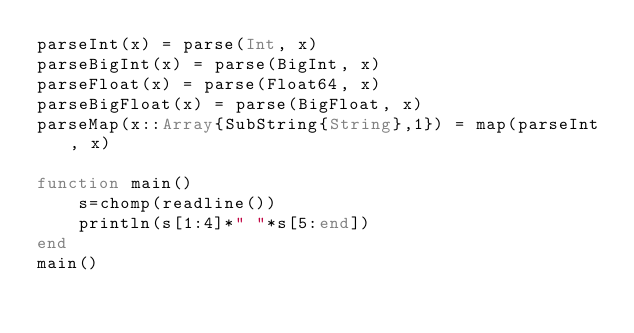Convert code to text. <code><loc_0><loc_0><loc_500><loc_500><_Julia_>parseInt(x) = parse(Int, x)
parseBigInt(x) = parse(BigInt, x)
parseFloat(x) = parse(Float64, x)
parseBigFloat(x) = parse(BigFloat, x)
parseMap(x::Array{SubString{String},1}) = map(parseInt, x)

function main()
    s=chomp(readline())
    println(s[1:4]*" "*s[5:end])
end
main()</code> 